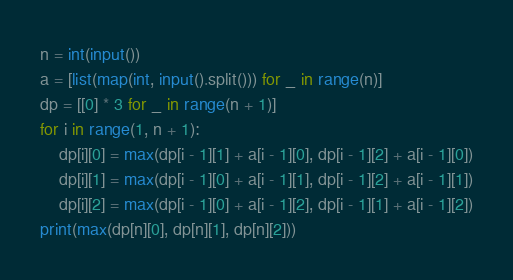Convert code to text. <code><loc_0><loc_0><loc_500><loc_500><_Python_>n = int(input())
a = [list(map(int, input().split())) for _ in range(n)]
dp = [[0] * 3 for _ in range(n + 1)]
for i in range(1, n + 1):
    dp[i][0] = max(dp[i - 1][1] + a[i - 1][0], dp[i - 1][2] + a[i - 1][0])
    dp[i][1] = max(dp[i - 1][0] + a[i - 1][1], dp[i - 1][2] + a[i - 1][1])
    dp[i][2] = max(dp[i - 1][0] + a[i - 1][2], dp[i - 1][1] + a[i - 1][2])
print(max(dp[n][0], dp[n][1], dp[n][2]))</code> 